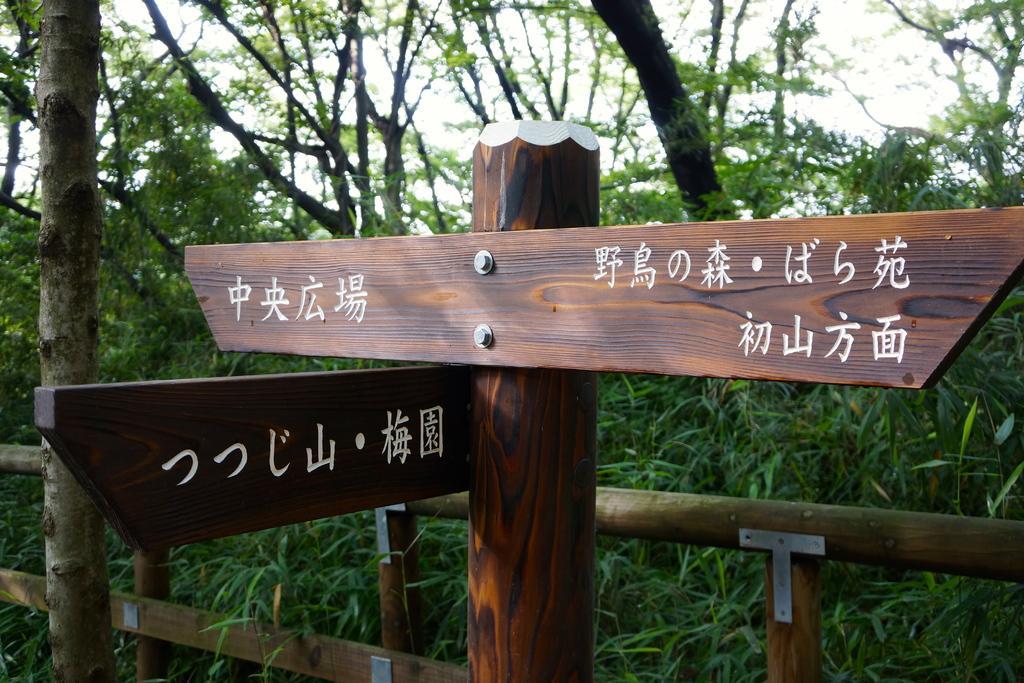Can you describe this image briefly? In the foreground of the image we can see boards with some text placed on a pole. In the background, we can see a barricade, group of trees and the sky. 